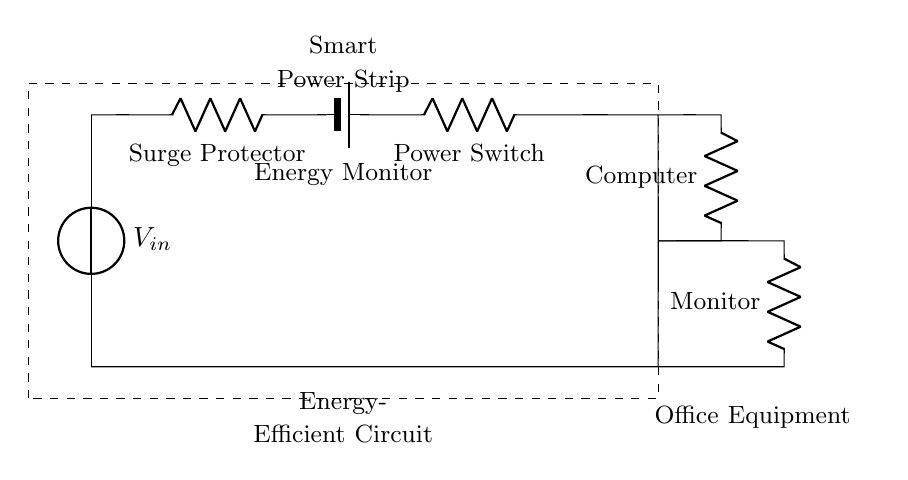What is the source voltage in this circuit? The source voltage is labeled as V_in in the diagram, indicating it is the input voltage supplied to the circuit.
Answer: V_in What components are connected in series before the office equipment? The components in series before the office equipment are the surge protector, energy monitor, and power switch, which are listed in the order they appear in the circuit.
Answer: Surge protector, energy monitor, power switch How many resistive components are in this circuit? The resistive components are the surge protector, power switch, computer, and monitor, totaling four resistive components connected in series.
Answer: Four If the power switch is off, what happens to the current in the circuit? When the power switch is off, it creates an open circuit, preventing any current from flowing through the entire series connection, thereby turning off all connected devices.
Answer: No current flows What is the function of the energy monitor in this circuit? The energy monitor tracks the energy consumption of the connected devices, providing insights into their usage and efficiency.
Answer: Energy consumption tracking Which office equipment is considered a load in this circuit? The computer and monitor are both loads in the circuit, consuming power from the energy source as part of the series connection.
Answer: Computer, monitor 